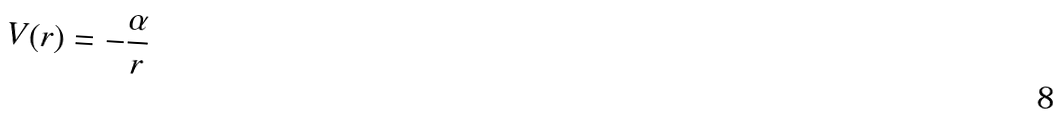Convert formula to latex. <formula><loc_0><loc_0><loc_500><loc_500>V ( r ) = - \frac { \alpha } { r }</formula> 